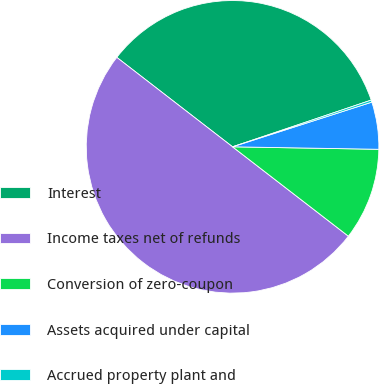<chart> <loc_0><loc_0><loc_500><loc_500><pie_chart><fcel>Interest<fcel>Income taxes net of refunds<fcel>Conversion of zero-coupon<fcel>Assets acquired under capital<fcel>Accrued property plant and<nl><fcel>34.36%<fcel>50.01%<fcel>10.19%<fcel>5.21%<fcel>0.23%<nl></chart> 